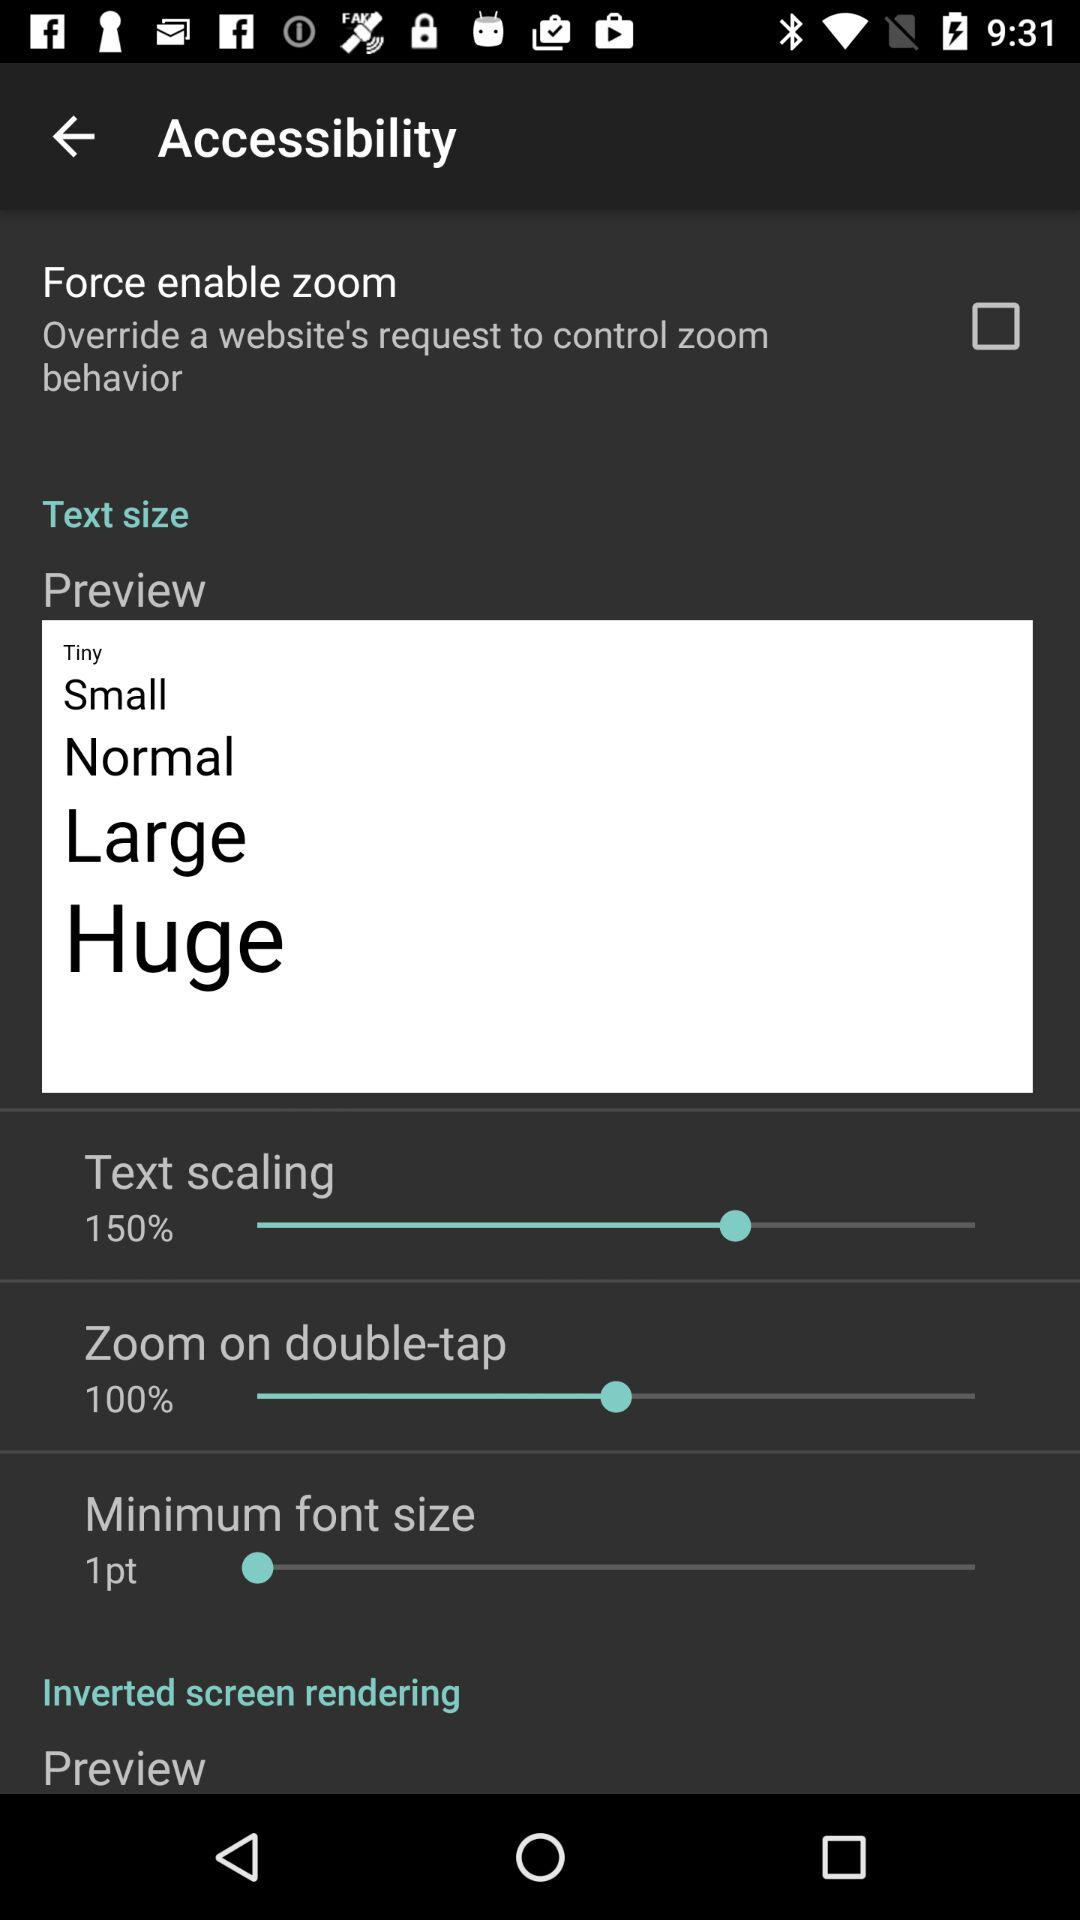Is "Preview" checked or unchecked?
When the provided information is insufficient, respond with <no answer>. <no answer> 